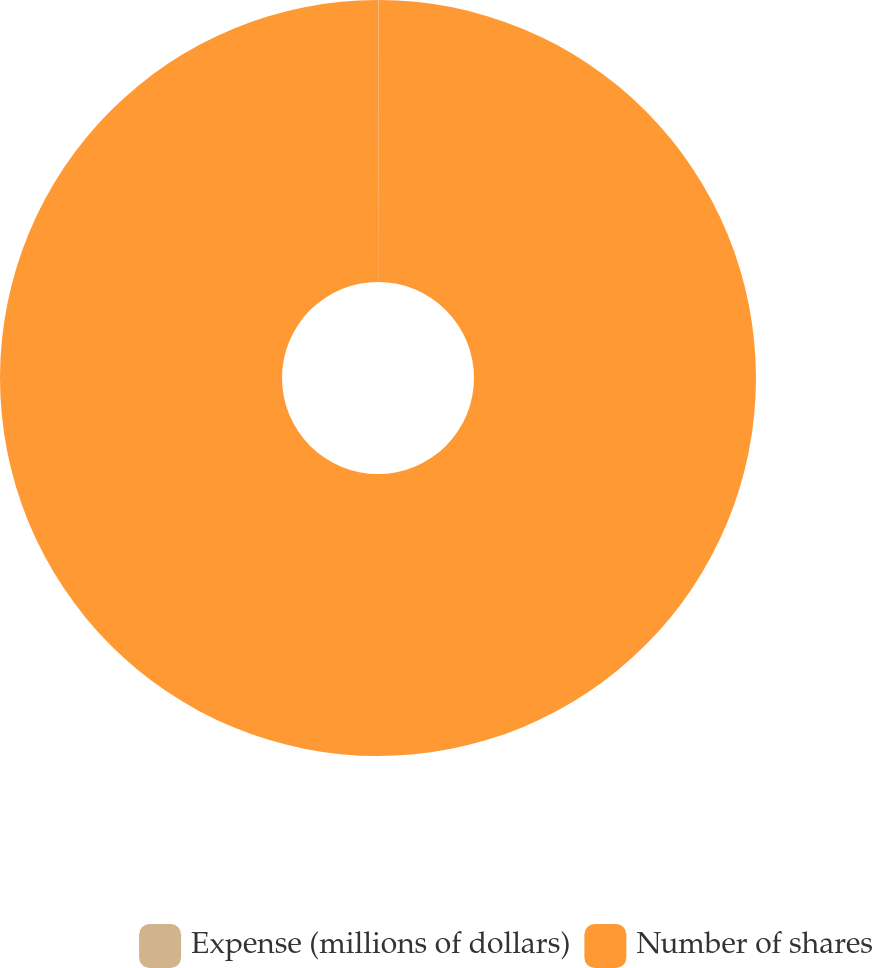Convert chart. <chart><loc_0><loc_0><loc_500><loc_500><pie_chart><fcel>Expense (millions of dollars)<fcel>Number of shares<nl><fcel>0.02%<fcel>99.98%<nl></chart> 